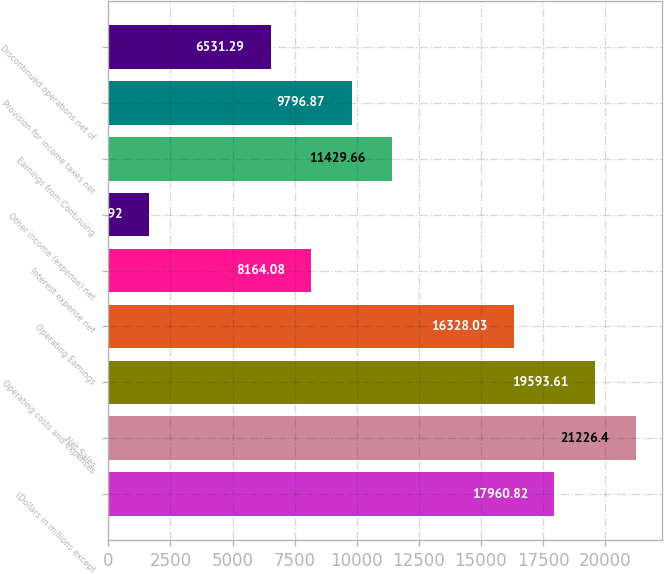Convert chart. <chart><loc_0><loc_0><loc_500><loc_500><bar_chart><fcel>(Dollars in millions except<fcel>Net Sales<fcel>Operating costs and expenses<fcel>Operating Earnings<fcel>Interest expense net<fcel>Other income (expense) net<fcel>Earnings from Continuing<fcel>Provision for income taxes net<fcel>Discontinued operations net of<nl><fcel>17960.8<fcel>21226.4<fcel>19593.6<fcel>16328<fcel>8164.08<fcel>1632.92<fcel>11429.7<fcel>9796.87<fcel>6531.29<nl></chart> 